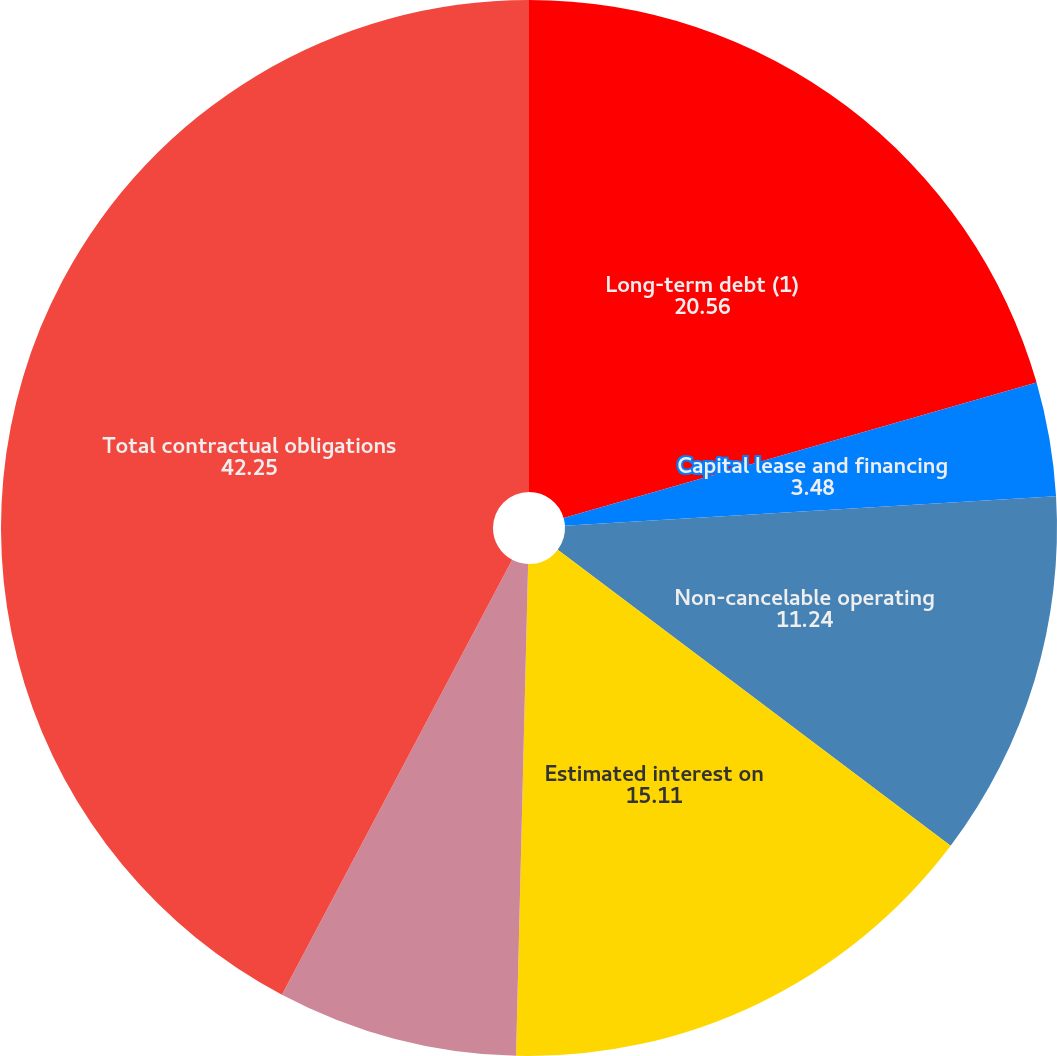<chart> <loc_0><loc_0><loc_500><loc_500><pie_chart><fcel>Long-term debt (1)<fcel>Capital lease and financing<fcel>Non-cancelable operating<fcel>Estimated interest on<fcel>Purchase obligations<fcel>Total contractual obligations<nl><fcel>20.56%<fcel>3.48%<fcel>11.24%<fcel>15.11%<fcel>7.36%<fcel>42.25%<nl></chart> 